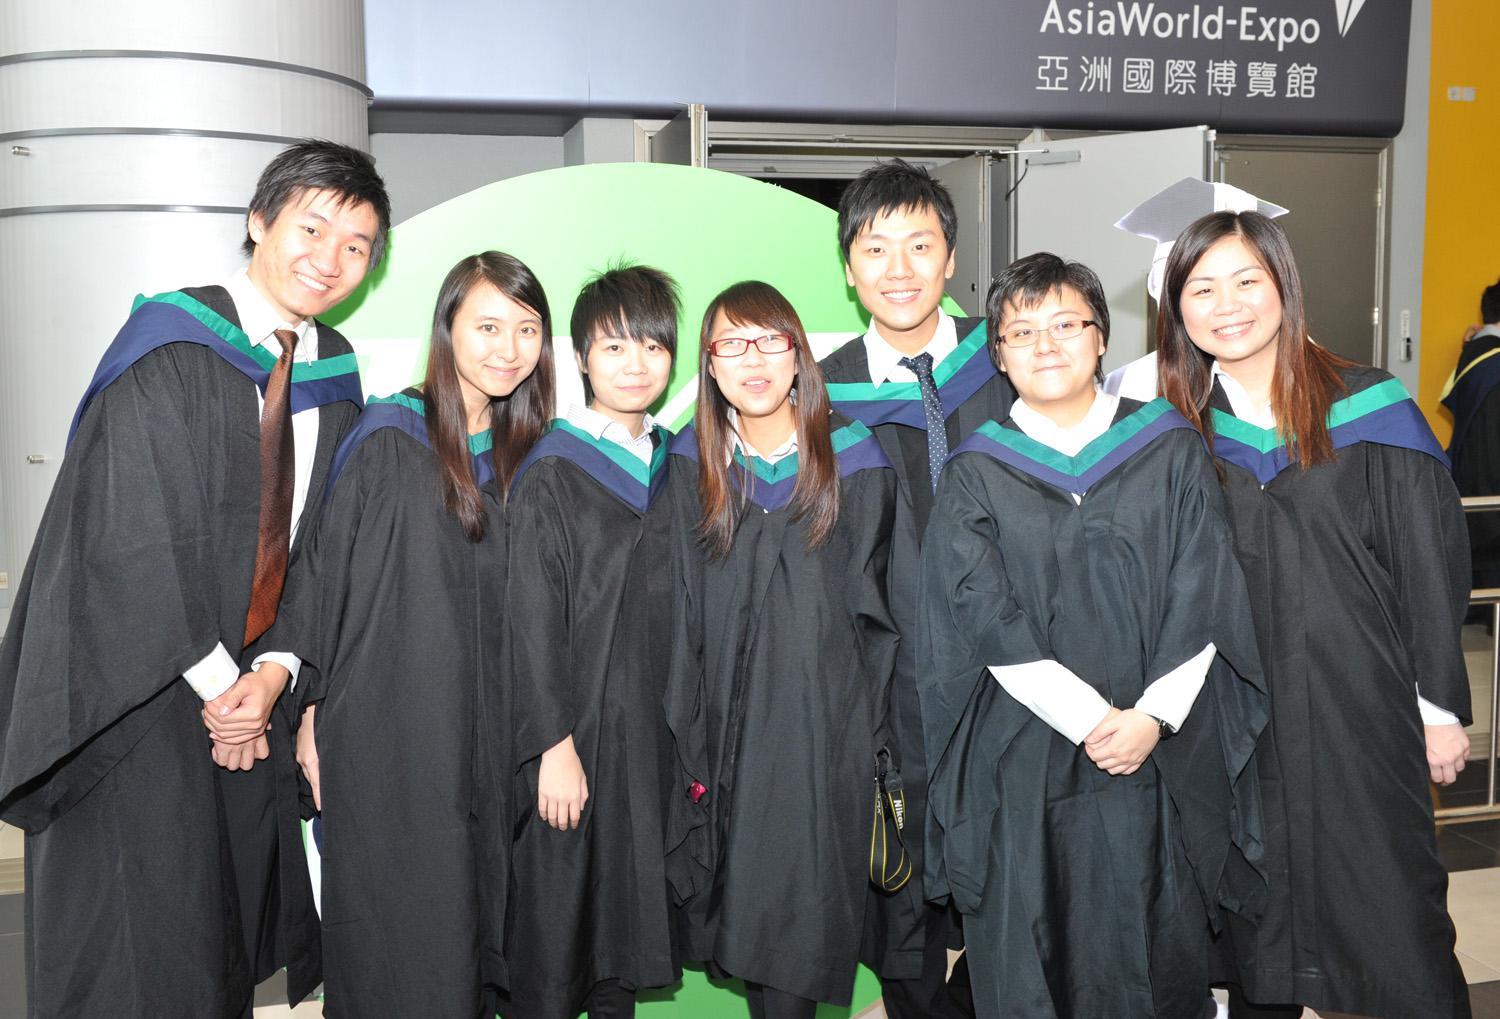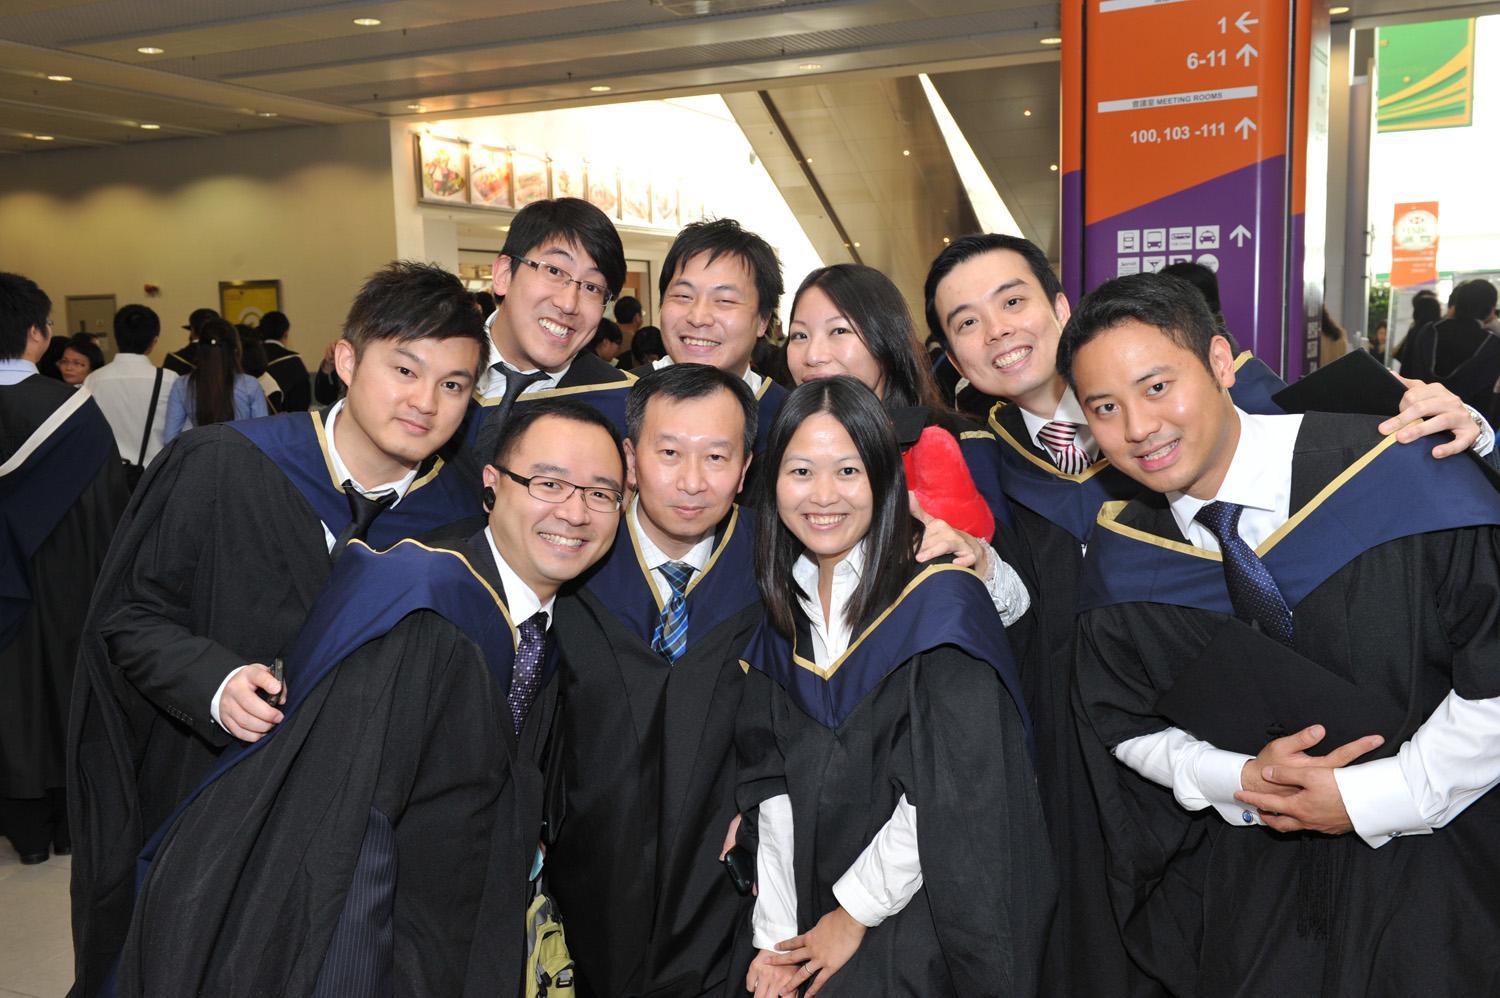The first image is the image on the left, the second image is the image on the right. Considering the images on both sides, is "The same number of graduates are shown in the left and right images." valid? Answer yes or no. No. 